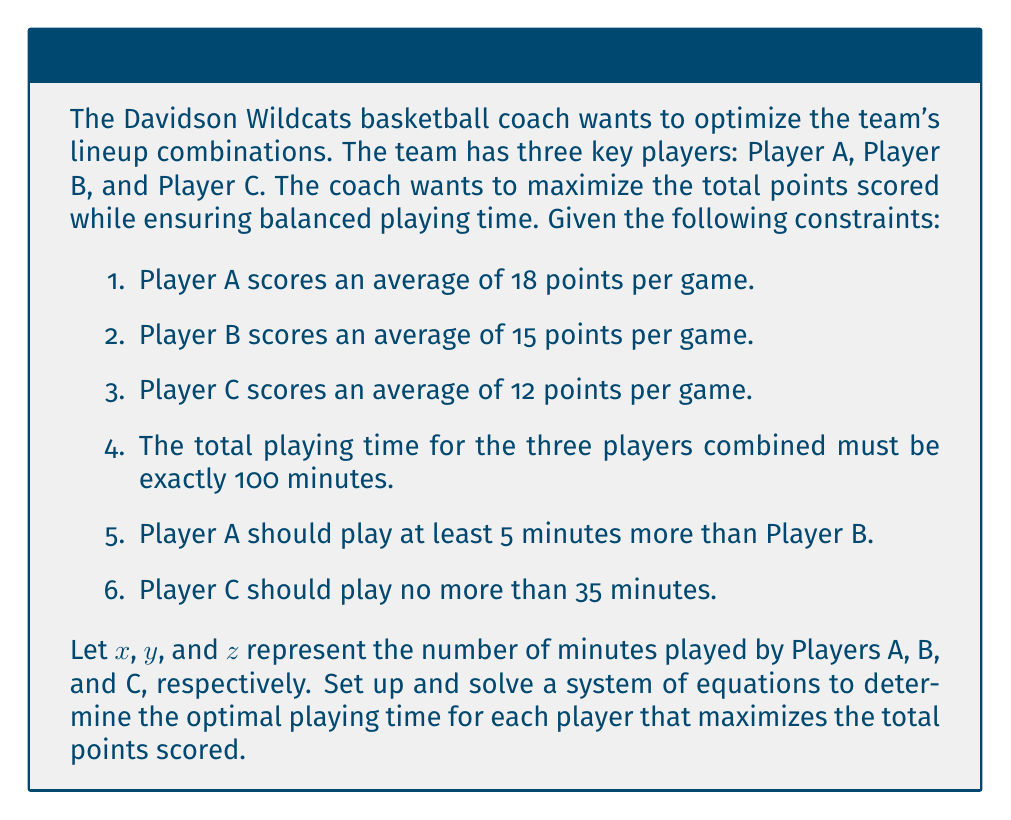Provide a solution to this math problem. Let's approach this problem step by step:

1. Set up the objective function to maximize total points:
   $$P = 18(\frac{x}{40}) + 15(\frac{y}{40}) + 12(\frac{z}{40})$$
   Here, we divide by 40 to convert the average points per game to points per minute.

2. Convert the constraints into equations:
   a. Total playing time: $x + y + z = 100$
   b. Player A plays at least 5 minutes more than B: $x \geq y + 5$
   c. Player C plays no more than 35 minutes: $z \leq 35$

3. To maximize P, we need to maximize x, y, and z while satisfying the constraints. Given the point values, we should prioritize more time for Player A, then B, then C.

4. Start by setting z to its maximum allowed value: $z = 35$

5. Now we have: $x + y = 65$ (from constraint a)

6. We know that $x = y + 5$ (to maximize playing time for both A and B while satisfying constraint b)

7. Substitute this into the equation from step 5:
   $(y + 5) + y = 65$
   $2y + 5 = 65$
   $2y = 60$
   $y = 30$

8. Now we can find x:
   $x = y + 5 = 30 + 5 = 35$

9. Verify that all constraints are satisfied:
   $x + y + z = 35 + 30 + 35 = 100$ (satisfies constraint a)
   $x = 35 > y + 5 = 35$ (satisfies constraint b)
   $z = 35 \leq 35$ (satisfies constraint c)

10. Calculate the total points scored:
    $$P = 18(\frac{35}{40}) + 15(\frac{30}{40}) + 12(\frac{35}{40}) = 15.75 + 11.25 + 10.5 = 37.5$$
Answer: The optimal playing time distribution that maximizes total points scored is:
Player A: 35 minutes
Player B: 30 minutes
Player C: 35 minutes
Total points scored: 37.5 